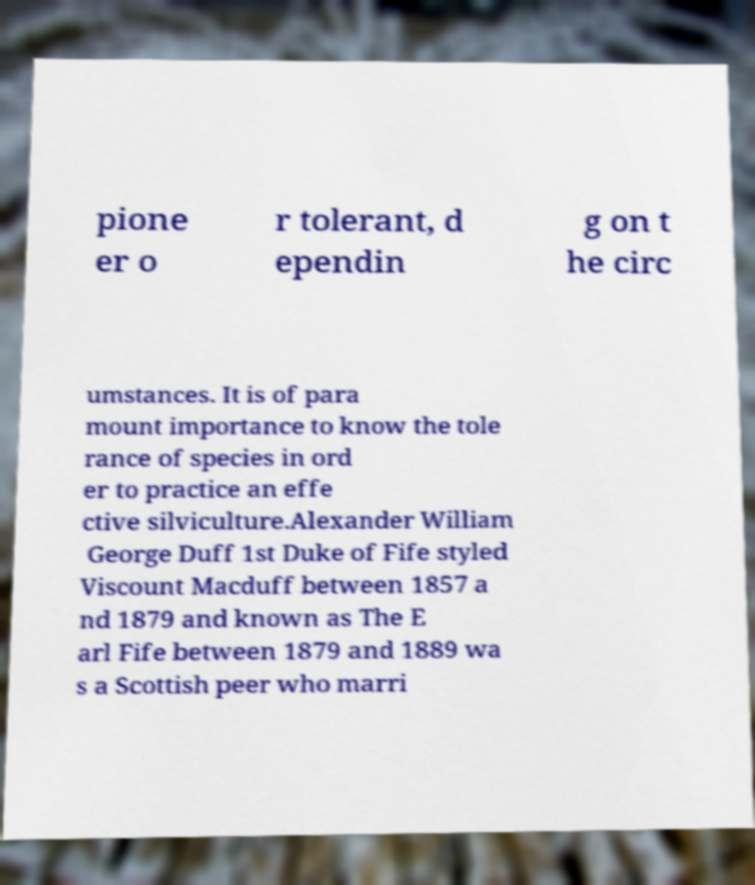For documentation purposes, I need the text within this image transcribed. Could you provide that? pione er o r tolerant, d ependin g on t he circ umstances. It is of para mount importance to know the tole rance of species in ord er to practice an effe ctive silviculture.Alexander William George Duff 1st Duke of Fife styled Viscount Macduff between 1857 a nd 1879 and known as The E arl Fife between 1879 and 1889 wa s a Scottish peer who marri 